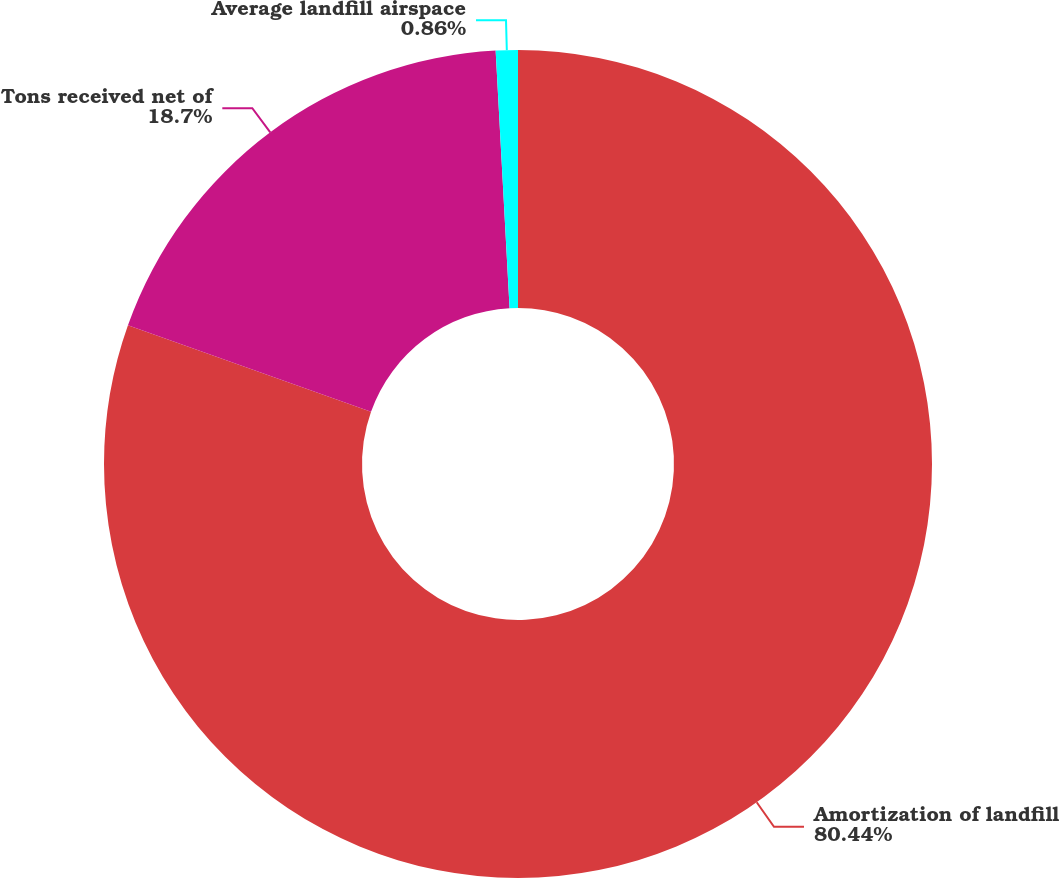Convert chart to OTSL. <chart><loc_0><loc_0><loc_500><loc_500><pie_chart><fcel>Amortization of landfill<fcel>Tons received net of<fcel>Average landfill airspace<nl><fcel>80.44%<fcel>18.7%<fcel>0.86%<nl></chart> 